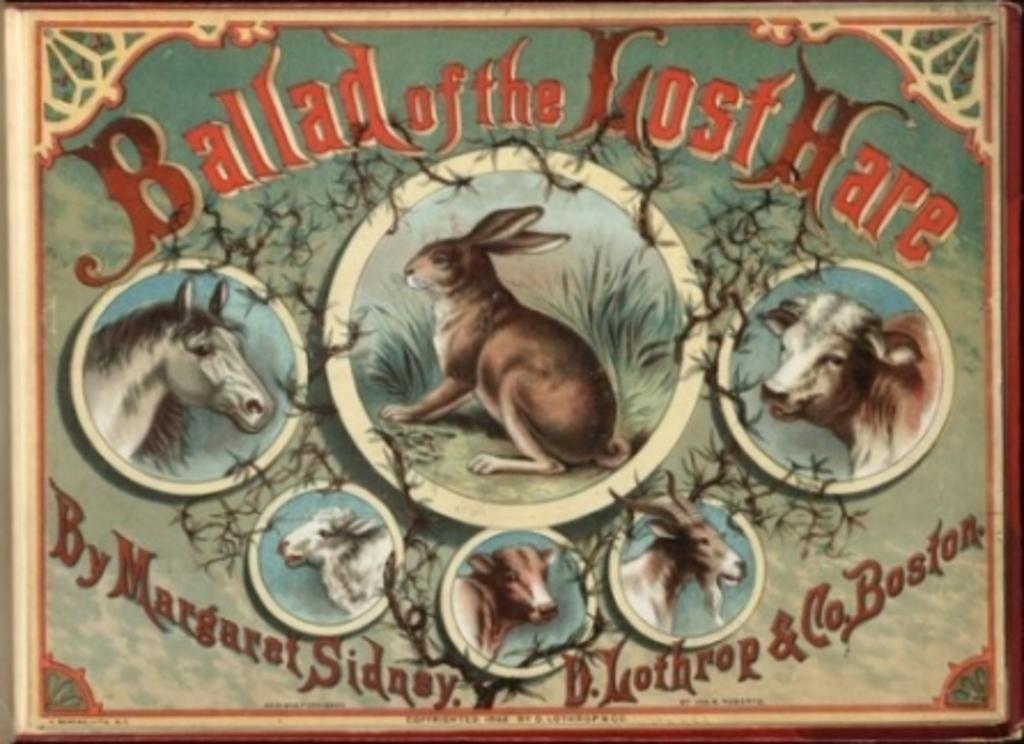What is the main subject of the image? The main subject of the image is a frame. What is depicted within the frame? The frame contains a depiction of animals. What type of environment is shown in the image? Grass is depicted in the image, suggesting a natural setting. Are there any words or letters in the image? Yes, there is text present in the image. Can you tell me how many kittens are playing with steam in the image? There are no kittens or steam present in the image; it features a frame with a depiction of animals and text. 